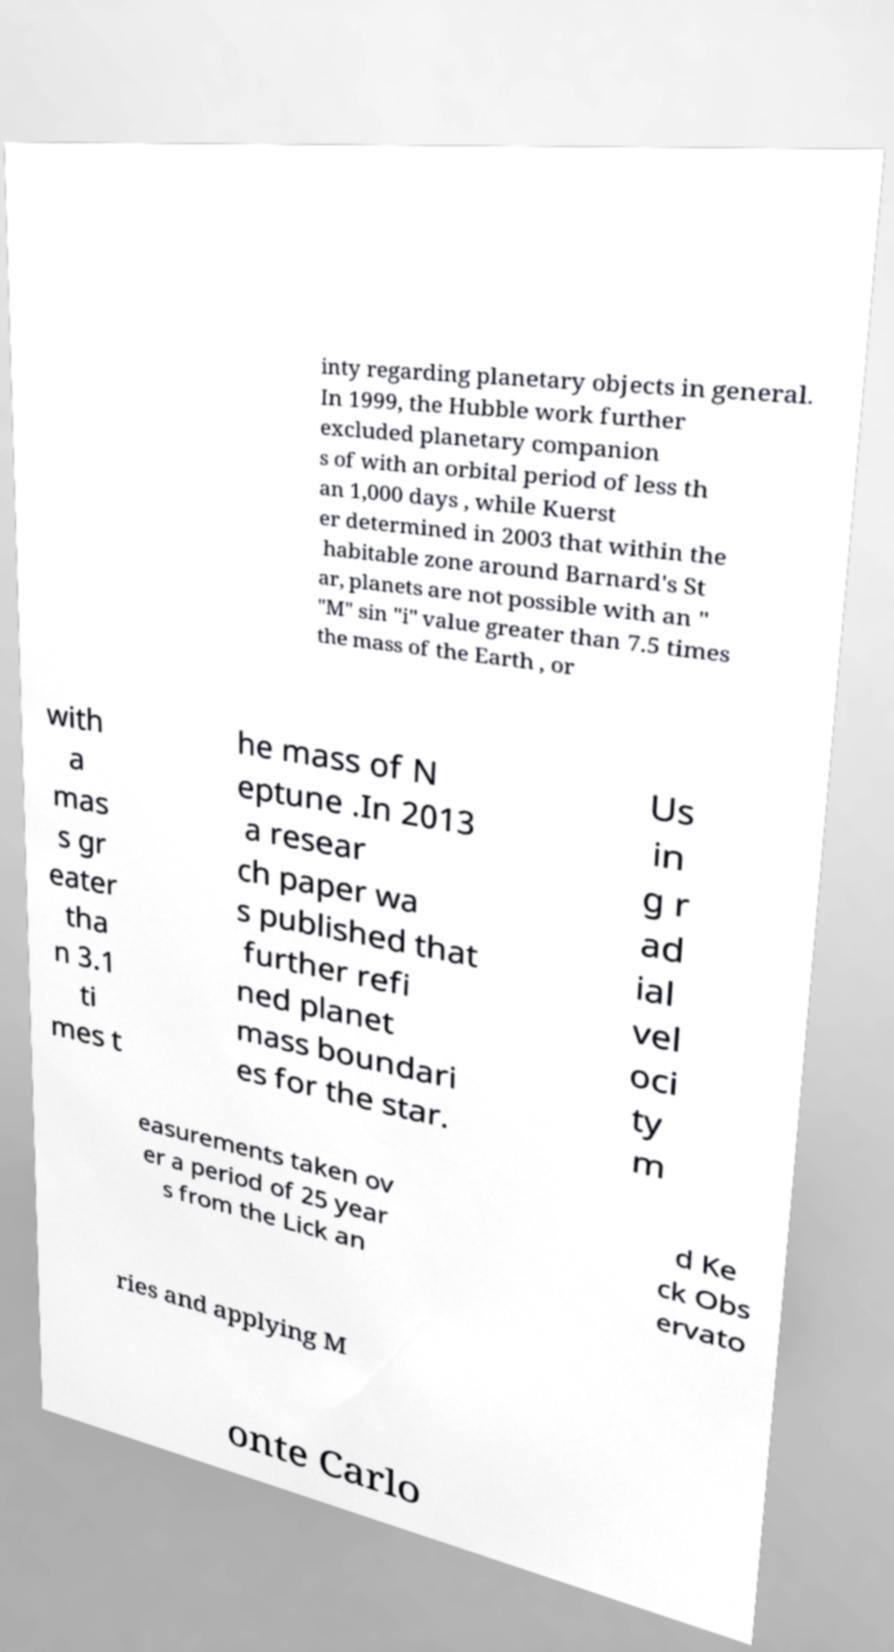Can you accurately transcribe the text from the provided image for me? inty regarding planetary objects in general. In 1999, the Hubble work further excluded planetary companion s of with an orbital period of less th an 1,000 days , while Kuerst er determined in 2003 that within the habitable zone around Barnard's St ar, planets are not possible with an " "M" sin "i" value greater than 7.5 times the mass of the Earth , or with a mas s gr eater tha n 3.1 ti mes t he mass of N eptune .In 2013 a resear ch paper wa s published that further refi ned planet mass boundari es for the star. Us in g r ad ial vel oci ty m easurements taken ov er a period of 25 year s from the Lick an d Ke ck Obs ervato ries and applying M onte Carlo 